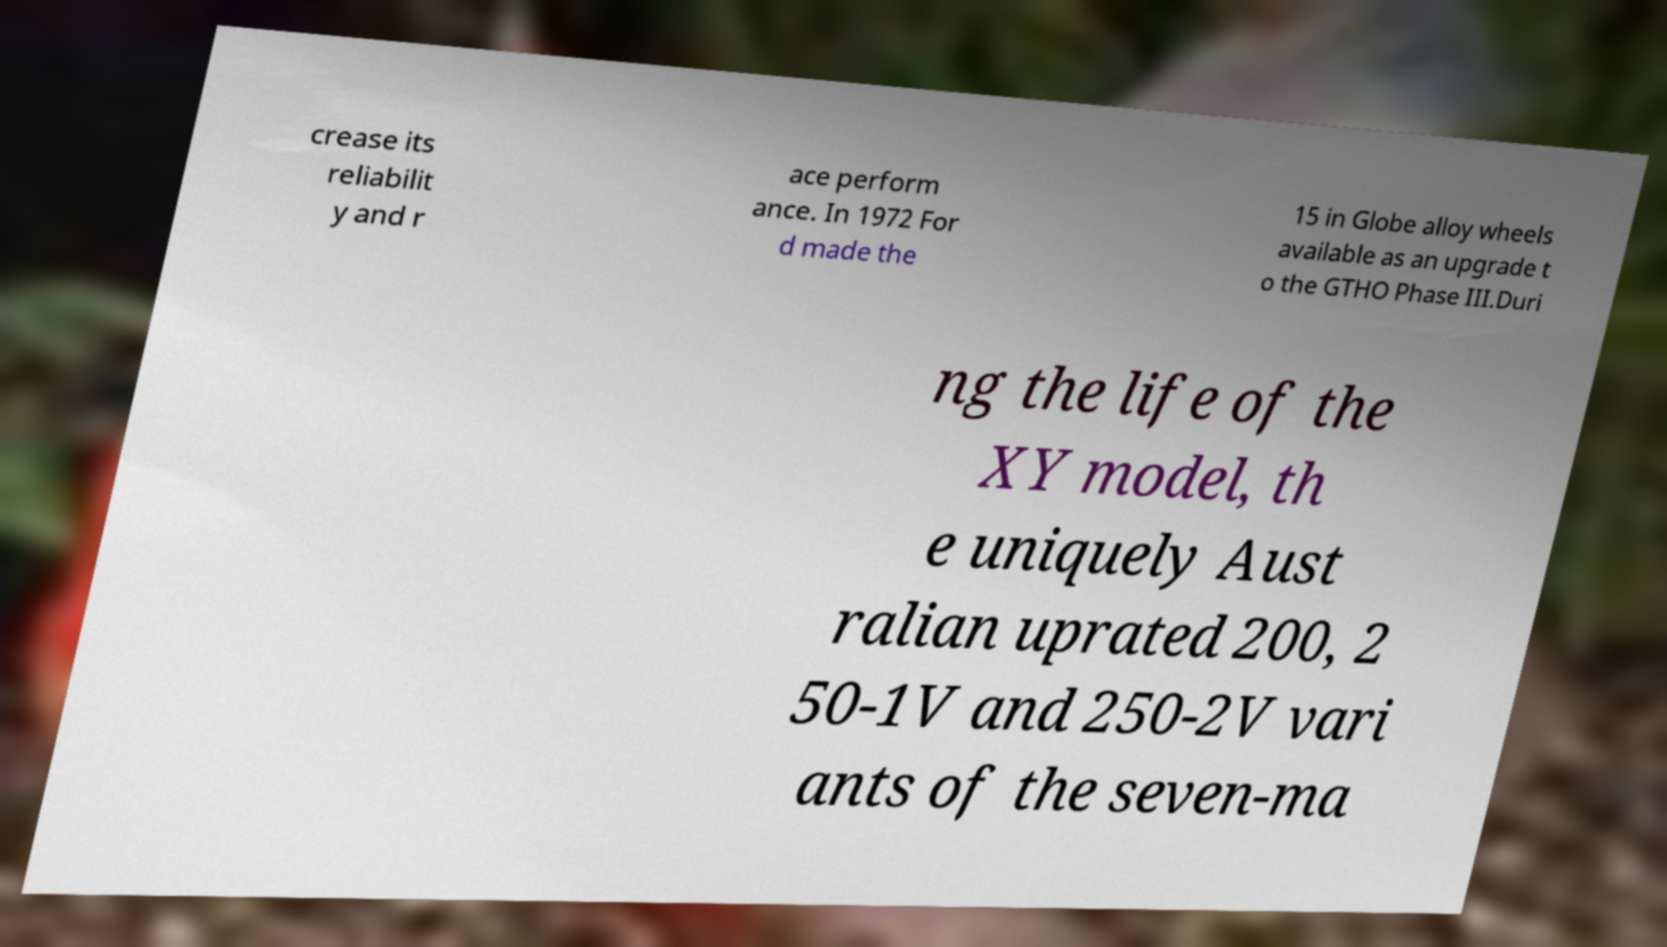Could you assist in decoding the text presented in this image and type it out clearly? crease its reliabilit y and r ace perform ance. In 1972 For d made the 15 in Globe alloy wheels available as an upgrade t o the GTHO Phase III.Duri ng the life of the XY model, th e uniquely Aust ralian uprated 200, 2 50-1V and 250-2V vari ants of the seven-ma 